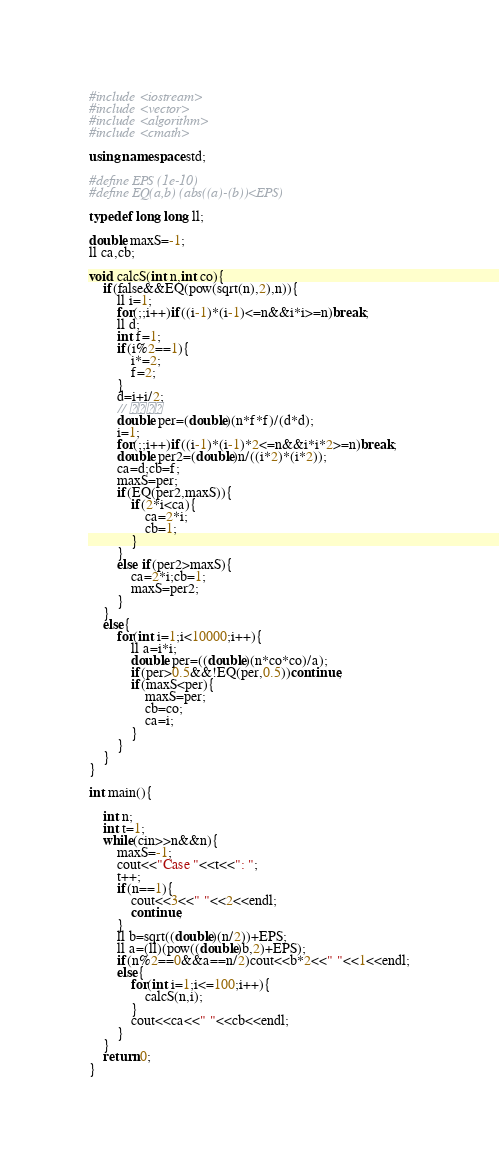<code> <loc_0><loc_0><loc_500><loc_500><_C++_>#include <iostream>
#include <vector>
#include <algorithm>
#include <cmath>

using namespace std;

#define EPS (1e-10)
#define EQ(a,b) (abs((a)-(b))<EPS)

typedef long long ll;

double maxS=-1;
ll ca,cb;

void calcS(int n,int co){
	if(false&&EQ(pow(sqrt(n),2),n)){
		ll i=1;
		for(;;i++)if((i-1)*(i-1)<=n&&i*i>=n)break;
		ll d;
		int f=1;
		if(i%2==1){
			i*=2;
			f=2;
		}
		d=i+i/2;
		// 
		double per=(double)(n*f*f)/(d*d);
		i=1;
		for(;;i++)if((i-1)*(i-1)*2<=n&&i*i*2>=n)break;
		double per2=(double)n/((i*2)*(i*2));
		ca=d;cb=f;
		maxS=per;
		if(EQ(per2,maxS)){
			if(2*i<ca){
				ca=2*i;
				cb=1;
			}
		}
		else if(per2>maxS){
			ca=2*i;cb=1;
			maxS=per2;
		}
	}
	else{
		for(int i=1;i<10000;i++){
			ll a=i*i;
			double per=((double)(n*co*co)/a);
			if(per>0.5&&!EQ(per,0.5))continue;
			if(maxS<per){
				maxS=per;
				cb=co;
				ca=i;
			}
		}
	}
}

int main(){

	int n;
	int t=1;
	while(cin>>n&&n){
		maxS=-1;
		cout<<"Case "<<t<<": ";
		t++;
		if(n==1){
			cout<<3<<" "<<2<<endl;
			continue;
		}
		ll b=sqrt((double)(n/2))+EPS;
		ll a=(ll)(pow((double)b,2)+EPS);
		if(n%2==0&&a==n/2)cout<<b*2<<" "<<1<<endl;
		else{
			for(int i=1;i<=100;i++){
				calcS(n,i);
			}
			cout<<ca<<" "<<cb<<endl;
		}
	}
	return 0;
}</code> 